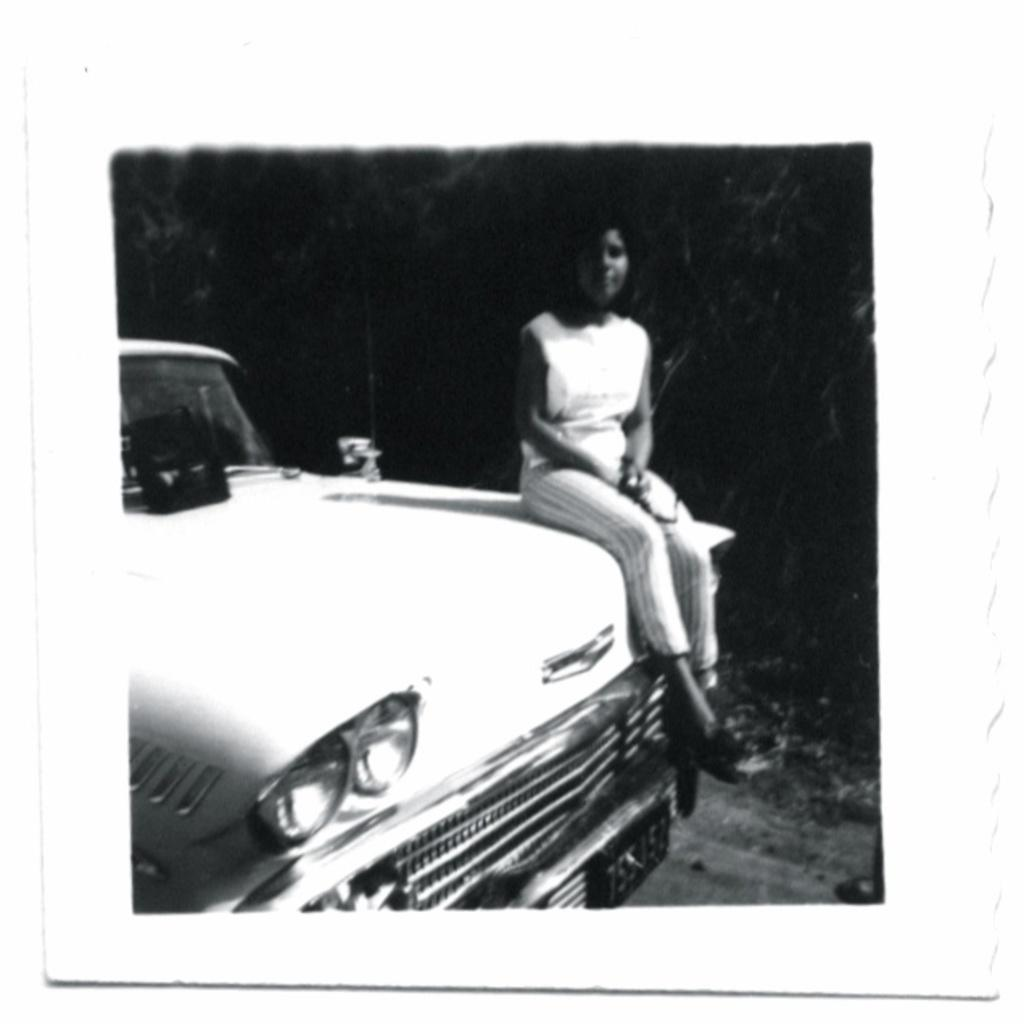What is the color scheme of the photo? The photo is black and white. What is the person in the photo doing? The person is sitting on a car. What can be seen in the background of the photo? There are trees in the background. What is at the bottom of the image? There is a road at the bottom of the image. What type of apparel is the person's brain wearing in the photo? There is no reference to a brain or apparel in the photo; it features a person sitting on a car with trees in the background and a road at the bottom. 